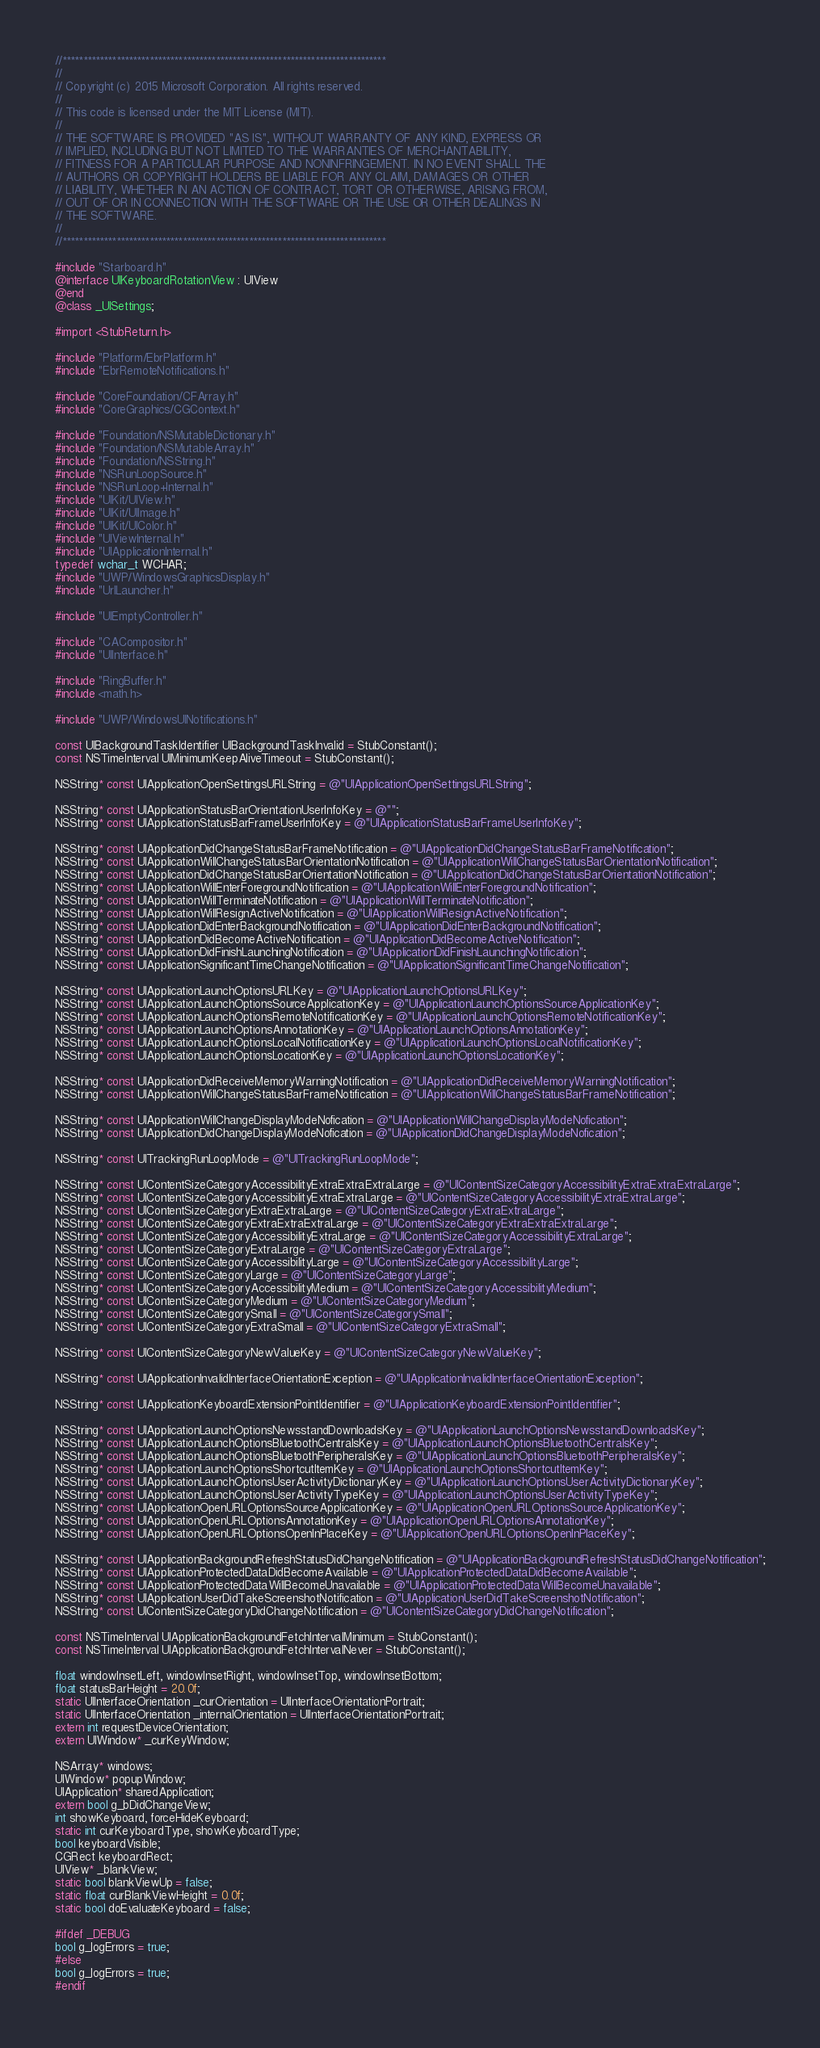Convert code to text. <code><loc_0><loc_0><loc_500><loc_500><_ObjectiveC_>//******************************************************************************
//
// Copyright (c) 2015 Microsoft Corporation. All rights reserved.
//
// This code is licensed under the MIT License (MIT).
//
// THE SOFTWARE IS PROVIDED "AS IS", WITHOUT WARRANTY OF ANY KIND, EXPRESS OR
// IMPLIED, INCLUDING BUT NOT LIMITED TO THE WARRANTIES OF MERCHANTABILITY,
// FITNESS FOR A PARTICULAR PURPOSE AND NONINFRINGEMENT. IN NO EVENT SHALL THE
// AUTHORS OR COPYRIGHT HOLDERS BE LIABLE FOR ANY CLAIM, DAMAGES OR OTHER
// LIABILITY, WHETHER IN AN ACTION OF CONTRACT, TORT OR OTHERWISE, ARISING FROM,
// OUT OF OR IN CONNECTION WITH THE SOFTWARE OR THE USE OR OTHER DEALINGS IN
// THE SOFTWARE.
//
//******************************************************************************

#include "Starboard.h"
@interface UIKeyboardRotationView : UIView
@end
@class _UISettings;

#import <StubReturn.h>

#include "Platform/EbrPlatform.h"
#include "EbrRemoteNotifications.h"

#include "CoreFoundation/CFArray.h"
#include "CoreGraphics/CGContext.h"

#include "Foundation/NSMutableDictionary.h"
#include "Foundation/NSMutableArray.h"
#include "Foundation/NSString.h"
#include "NSRunLoopSource.h"
#include "NSRunLoop+Internal.h"
#include "UIKit/UIView.h"
#include "UIKit/UIImage.h"
#include "UIKit/UIColor.h"
#include "UIViewInternal.h"
#include "UIApplicationInternal.h"
typedef wchar_t WCHAR;
#include "UWP/WindowsGraphicsDisplay.h"
#include "UrlLauncher.h"

#include "UIEmptyController.h"

#include "CACompositor.h"
#include "UIInterface.h"

#include "RingBuffer.h"
#include <math.h>

#include "UWP/WindowsUINotifications.h"

const UIBackgroundTaskIdentifier UIBackgroundTaskInvalid = StubConstant();
const NSTimeInterval UIMinimumKeepAliveTimeout = StubConstant();

NSString* const UIApplicationOpenSettingsURLString = @"UIApplicationOpenSettingsURLString";

NSString* const UIApplicationStatusBarOrientationUserInfoKey = @"";
NSString* const UIApplicationStatusBarFrameUserInfoKey = @"UIApplicationStatusBarFrameUserInfoKey";

NSString* const UIApplicationDidChangeStatusBarFrameNotification = @"UIApplicationDidChangeStatusBarFrameNotification";
NSString* const UIApplicationWillChangeStatusBarOrientationNotification = @"UIApplicationWillChangeStatusBarOrientationNotification";
NSString* const UIApplicationDidChangeStatusBarOrientationNotification = @"UIApplicationDidChangeStatusBarOrientationNotification";
NSString* const UIApplicationWillEnterForegroundNotification = @"UIApplicationWillEnterForegroundNotification";
NSString* const UIApplicationWillTerminateNotification = @"UIApplicationWillTerminateNotification";
NSString* const UIApplicationWillResignActiveNotification = @"UIApplicationWillResignActiveNotification";
NSString* const UIApplicationDidEnterBackgroundNotification = @"UIApplicationDidEnterBackgroundNotification";
NSString* const UIApplicationDidBecomeActiveNotification = @"UIApplicationDidBecomeActiveNotification";
NSString* const UIApplicationDidFinishLaunchingNotification = @"UIApplicationDidFinishLaunchingNotification";
NSString* const UIApplicationSignificantTimeChangeNotification = @"UIApplicationSignificantTimeChangeNotification";

NSString* const UIApplicationLaunchOptionsURLKey = @"UIApplicationLaunchOptionsURLKey";
NSString* const UIApplicationLaunchOptionsSourceApplicationKey = @"UIApplicationLaunchOptionsSourceApplicationKey";
NSString* const UIApplicationLaunchOptionsRemoteNotificationKey = @"UIApplicationLaunchOptionsRemoteNotificationKey";
NSString* const UIApplicationLaunchOptionsAnnotationKey = @"UIApplicationLaunchOptionsAnnotationKey";
NSString* const UIApplicationLaunchOptionsLocalNotificationKey = @"UIApplicationLaunchOptionsLocalNotificationKey";
NSString* const UIApplicationLaunchOptionsLocationKey = @"UIApplicationLaunchOptionsLocationKey";

NSString* const UIApplicationDidReceiveMemoryWarningNotification = @"UIApplicationDidReceiveMemoryWarningNotification";
NSString* const UIApplicationWillChangeStatusBarFrameNotification = @"UIApplicationWillChangeStatusBarFrameNotification";

NSString* const UIApplicationWillChangeDisplayModeNofication = @"UIApplicationWillChangeDisplayModeNofication";
NSString* const UIApplicationDidChangeDisplayModeNofication = @"UIApplicationDidChangeDisplayModeNofication";

NSString* const UITrackingRunLoopMode = @"UITrackingRunLoopMode";

NSString* const UIContentSizeCategoryAccessibilityExtraExtraExtraLarge = @"UIContentSizeCategoryAccessibilityExtraExtraExtraLarge";
NSString* const UIContentSizeCategoryAccessibilityExtraExtraLarge = @"UIContentSizeCategoryAccessibilityExtraExtraLarge";
NSString* const UIContentSizeCategoryExtraExtraLarge = @"UIContentSizeCategoryExtraExtraLarge";
NSString* const UIContentSizeCategoryExtraExtraExtraLarge = @"UIContentSizeCategoryExtraExtraExtraLarge";
NSString* const UIContentSizeCategoryAccessibilityExtraLarge = @"UIContentSizeCategoryAccessibilityExtraLarge";
NSString* const UIContentSizeCategoryExtraLarge = @"UIContentSizeCategoryExtraLarge";
NSString* const UIContentSizeCategoryAccessibilityLarge = @"UIContentSizeCategoryAccessibilityLarge";
NSString* const UIContentSizeCategoryLarge = @"UIContentSizeCategoryLarge";
NSString* const UIContentSizeCategoryAccessibilityMedium = @"UIContentSizeCategoryAccessibilityMedium";
NSString* const UIContentSizeCategoryMedium = @"UIContentSizeCategoryMedium";
NSString* const UIContentSizeCategorySmall = @"UIContentSizeCategorySmall";
NSString* const UIContentSizeCategoryExtraSmall = @"UIContentSizeCategoryExtraSmall";

NSString* const UIContentSizeCategoryNewValueKey = @"UIContentSizeCategoryNewValueKey";

NSString* const UIApplicationInvalidInterfaceOrientationException = @"UIApplicationInvalidInterfaceOrientationException";

NSString* const UIApplicationKeyboardExtensionPointIdentifier = @"UIApplicationKeyboardExtensionPointIdentifier";

NSString* const UIApplicationLaunchOptionsNewsstandDownloadsKey = @"UIApplicationLaunchOptionsNewsstandDownloadsKey";
NSString* const UIApplicationLaunchOptionsBluetoothCentralsKey = @"UIApplicationLaunchOptionsBluetoothCentralsKey";
NSString* const UIApplicationLaunchOptionsBluetoothPeripheralsKey = @"UIApplicationLaunchOptionsBluetoothPeripheralsKey";
NSString* const UIApplicationLaunchOptionsShortcutItemKey = @"UIApplicationLaunchOptionsShortcutItemKey";
NSString* const UIApplicationLaunchOptionsUserActivityDictionaryKey = @"UIApplicationLaunchOptionsUserActivityDictionaryKey";
NSString* const UIApplicationLaunchOptionsUserActivityTypeKey = @"UIApplicationLaunchOptionsUserActivityTypeKey";
NSString* const UIApplicationOpenURLOptionsSourceApplicationKey = @"UIApplicationOpenURLOptionsSourceApplicationKey";
NSString* const UIApplicationOpenURLOptionsAnnotationKey = @"UIApplicationOpenURLOptionsAnnotationKey";
NSString* const UIApplicationOpenURLOptionsOpenInPlaceKey = @"UIApplicationOpenURLOptionsOpenInPlaceKey";

NSString* const UIApplicationBackgroundRefreshStatusDidChangeNotification = @"UIApplicationBackgroundRefreshStatusDidChangeNotification";
NSString* const UIApplicationProtectedDataDidBecomeAvailable = @"UIApplicationProtectedDataDidBecomeAvailable";
NSString* const UIApplicationProtectedDataWillBecomeUnavailable = @"UIApplicationProtectedDataWillBecomeUnavailable";
NSString* const UIApplicationUserDidTakeScreenshotNotification = @"UIApplicationUserDidTakeScreenshotNotification";
NSString* const UIContentSizeCategoryDidChangeNotification = @"UIContentSizeCategoryDidChangeNotification";

const NSTimeInterval UIApplicationBackgroundFetchIntervalMinimum = StubConstant();
const NSTimeInterval UIApplicationBackgroundFetchIntervalNever = StubConstant();

float windowInsetLeft, windowInsetRight, windowInsetTop, windowInsetBottom;
float statusBarHeight = 20.0f;
static UIInterfaceOrientation _curOrientation = UIInterfaceOrientationPortrait;
static UIInterfaceOrientation _internalOrientation = UIInterfaceOrientationPortrait;
extern int requestDeviceOrientation;
extern UIWindow* _curKeyWindow;

NSArray* windows;
UIWindow* popupWindow;
UIApplication* sharedApplication;
extern bool g_bDidChangeView;
int showKeyboard, forceHideKeyboard;
static int curKeyboardType, showKeyboardType;
bool keyboardVisible;
CGRect keyboardRect;
UIView* _blankView;
static bool blankViewUp = false;
static float curBlankViewHeight = 0.0f;
static bool doEvaluateKeyboard = false;

#ifdef _DEBUG
bool g_logErrors = true;
#else
bool g_logErrors = true;
#endif
</code> 